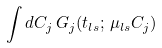Convert formula to latex. <formula><loc_0><loc_0><loc_500><loc_500>\int d C _ { j } \, { G } _ { j } ( t _ { l s } ; \, \mu _ { l s } C _ { j } )</formula> 